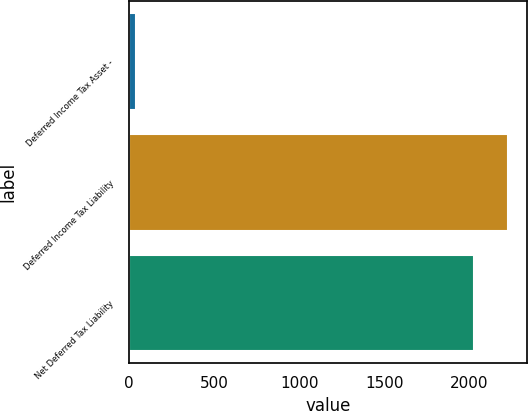Convert chart. <chart><loc_0><loc_0><loc_500><loc_500><bar_chart><fcel>Deferred Income Tax Asset -<fcel>Deferred Income Tax Liability<fcel>Net Deferred Tax Liability<nl><fcel>41<fcel>2225.8<fcel>2024<nl></chart> 